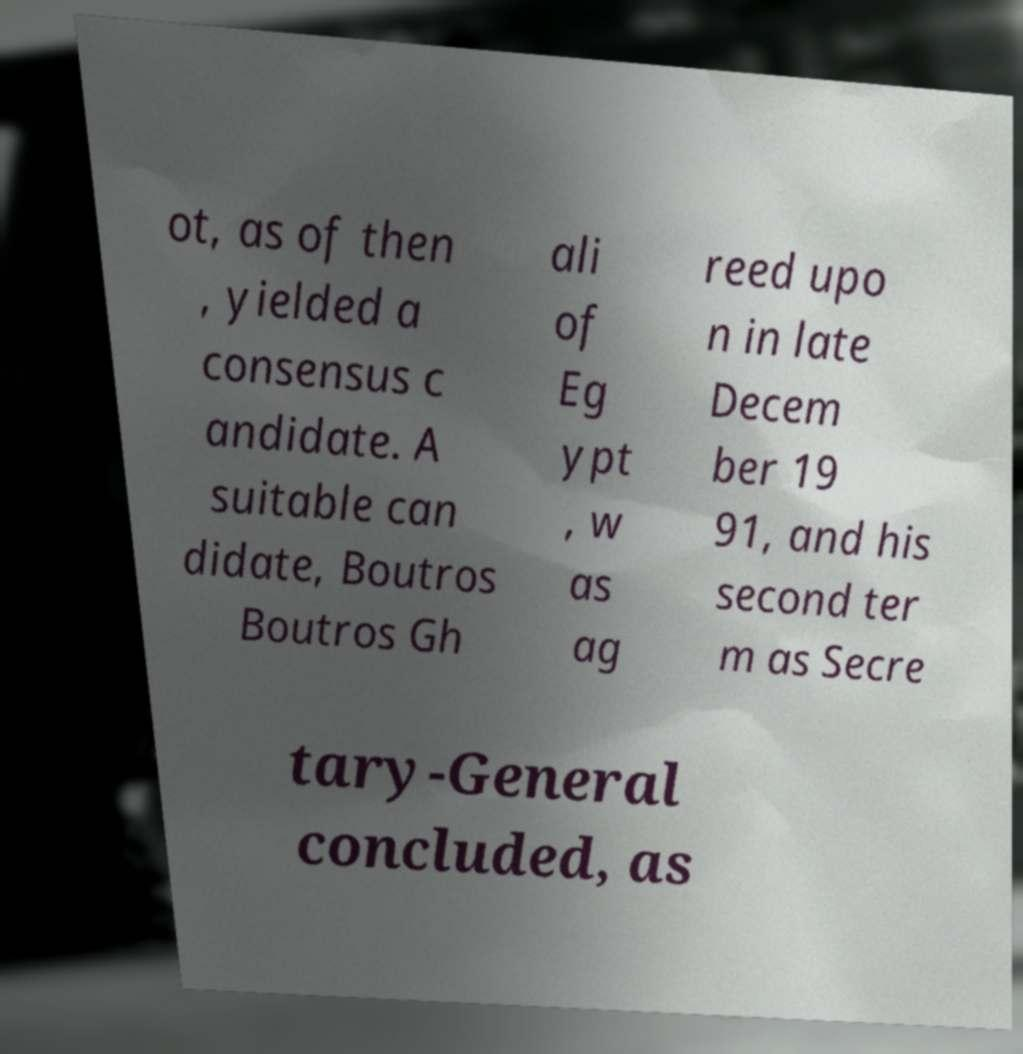What messages or text are displayed in this image? I need them in a readable, typed format. ot, as of then , yielded a consensus c andidate. A suitable can didate, Boutros Boutros Gh ali of Eg ypt , w as ag reed upo n in late Decem ber 19 91, and his second ter m as Secre tary-General concluded, as 